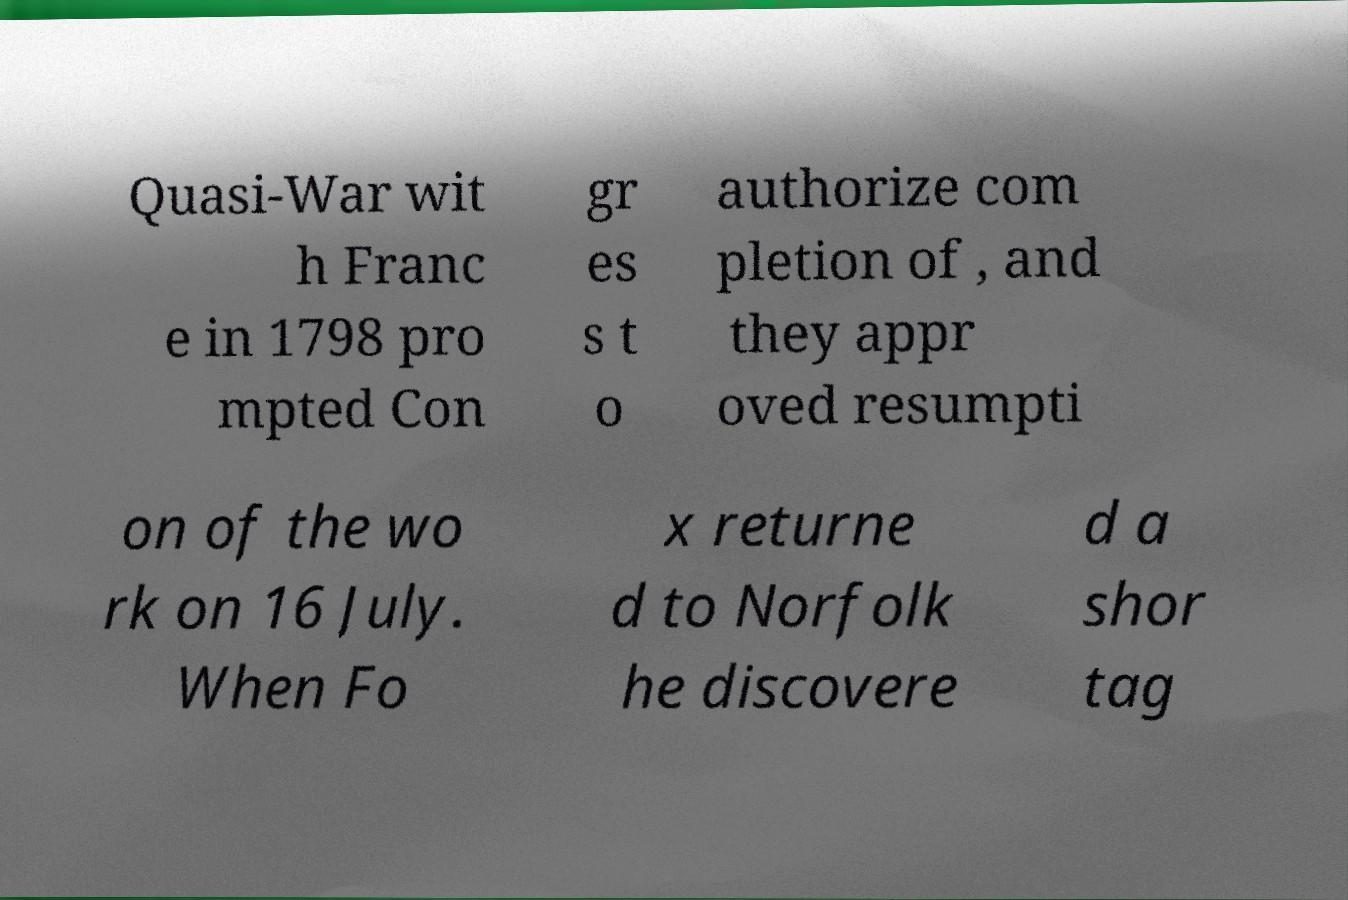Can you read and provide the text displayed in the image?This photo seems to have some interesting text. Can you extract and type it out for me? Quasi-War wit h Franc e in 1798 pro mpted Con gr es s t o authorize com pletion of , and they appr oved resumpti on of the wo rk on 16 July. When Fo x returne d to Norfolk he discovere d a shor tag 